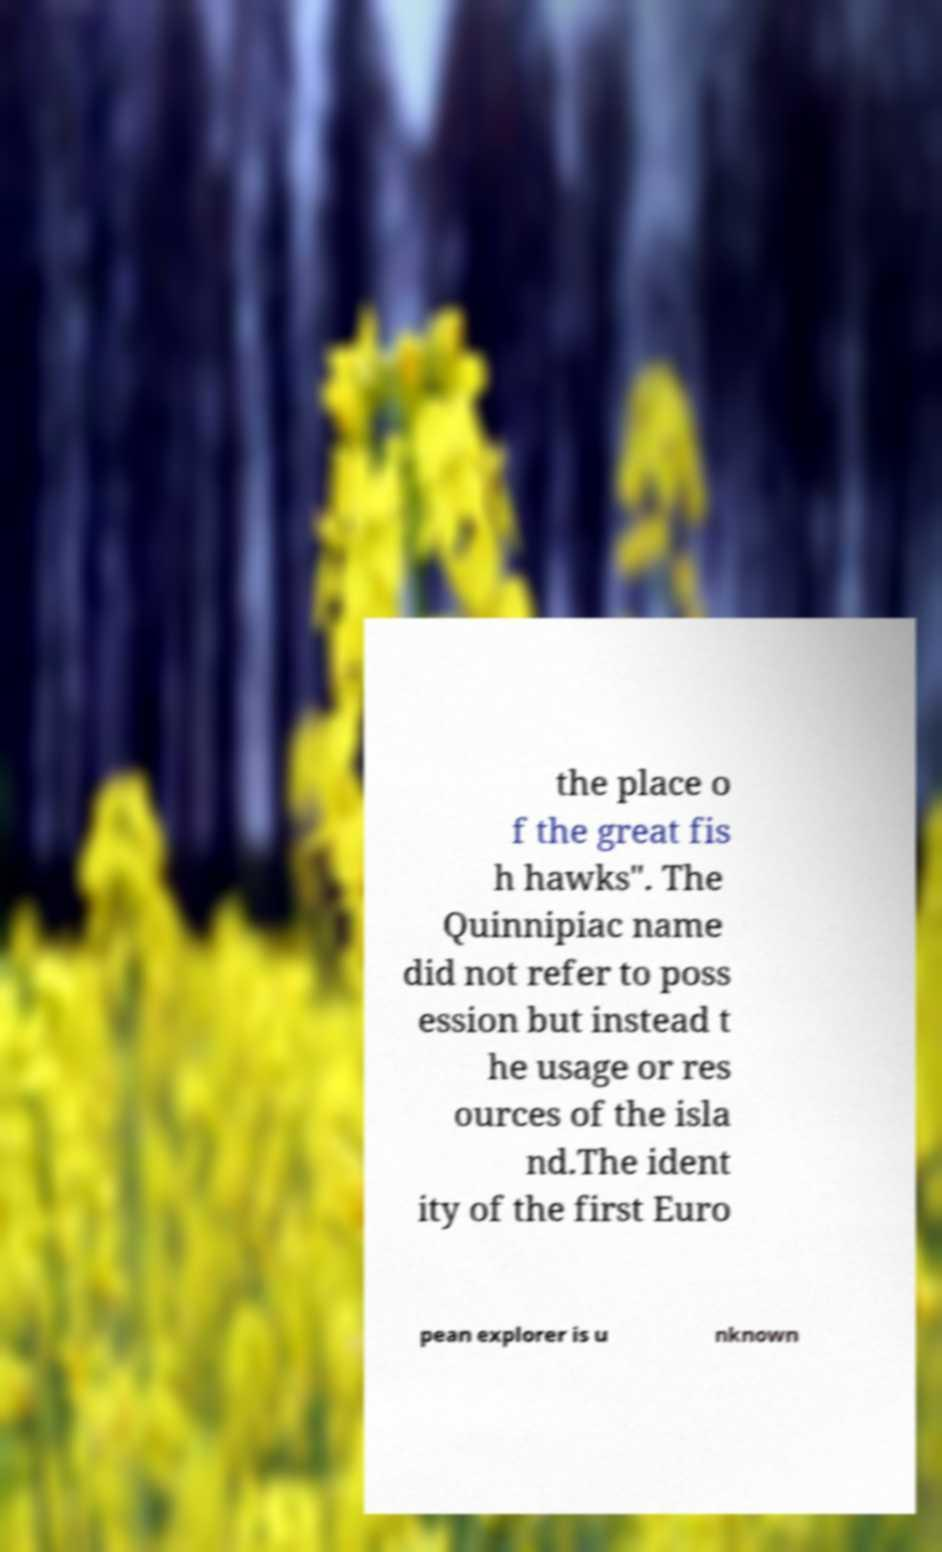What messages or text are displayed in this image? I need them in a readable, typed format. the place o f the great fis h hawks". The Quinnipiac name did not refer to poss ession but instead t he usage or res ources of the isla nd.The ident ity of the first Euro pean explorer is u nknown 